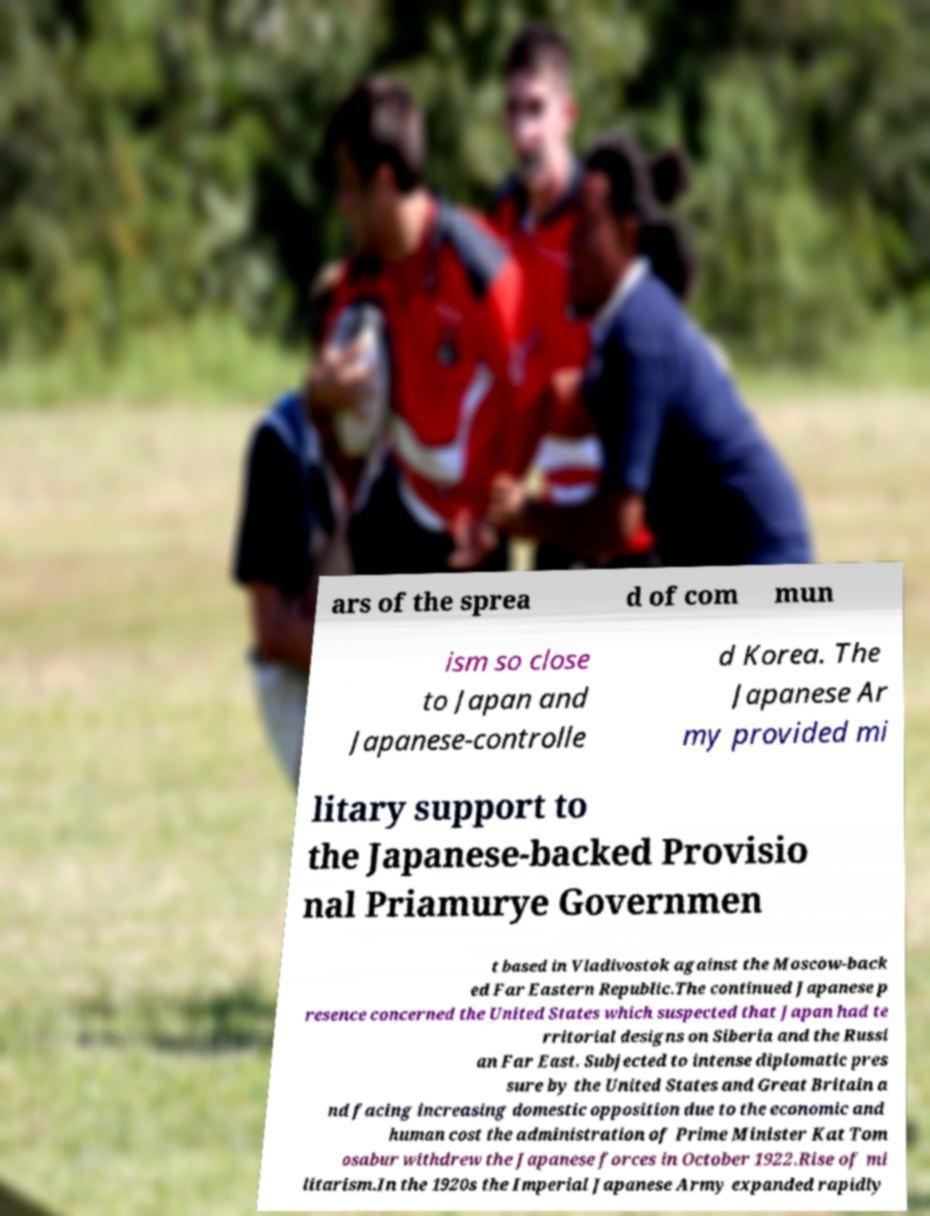Could you extract and type out the text from this image? ars of the sprea d of com mun ism so close to Japan and Japanese-controlle d Korea. The Japanese Ar my provided mi litary support to the Japanese-backed Provisio nal Priamurye Governmen t based in Vladivostok against the Moscow-back ed Far Eastern Republic.The continued Japanese p resence concerned the United States which suspected that Japan had te rritorial designs on Siberia and the Russi an Far East. Subjected to intense diplomatic pres sure by the United States and Great Britain a nd facing increasing domestic opposition due to the economic and human cost the administration of Prime Minister Kat Tom osabur withdrew the Japanese forces in October 1922.Rise of mi litarism.In the 1920s the Imperial Japanese Army expanded rapidly 